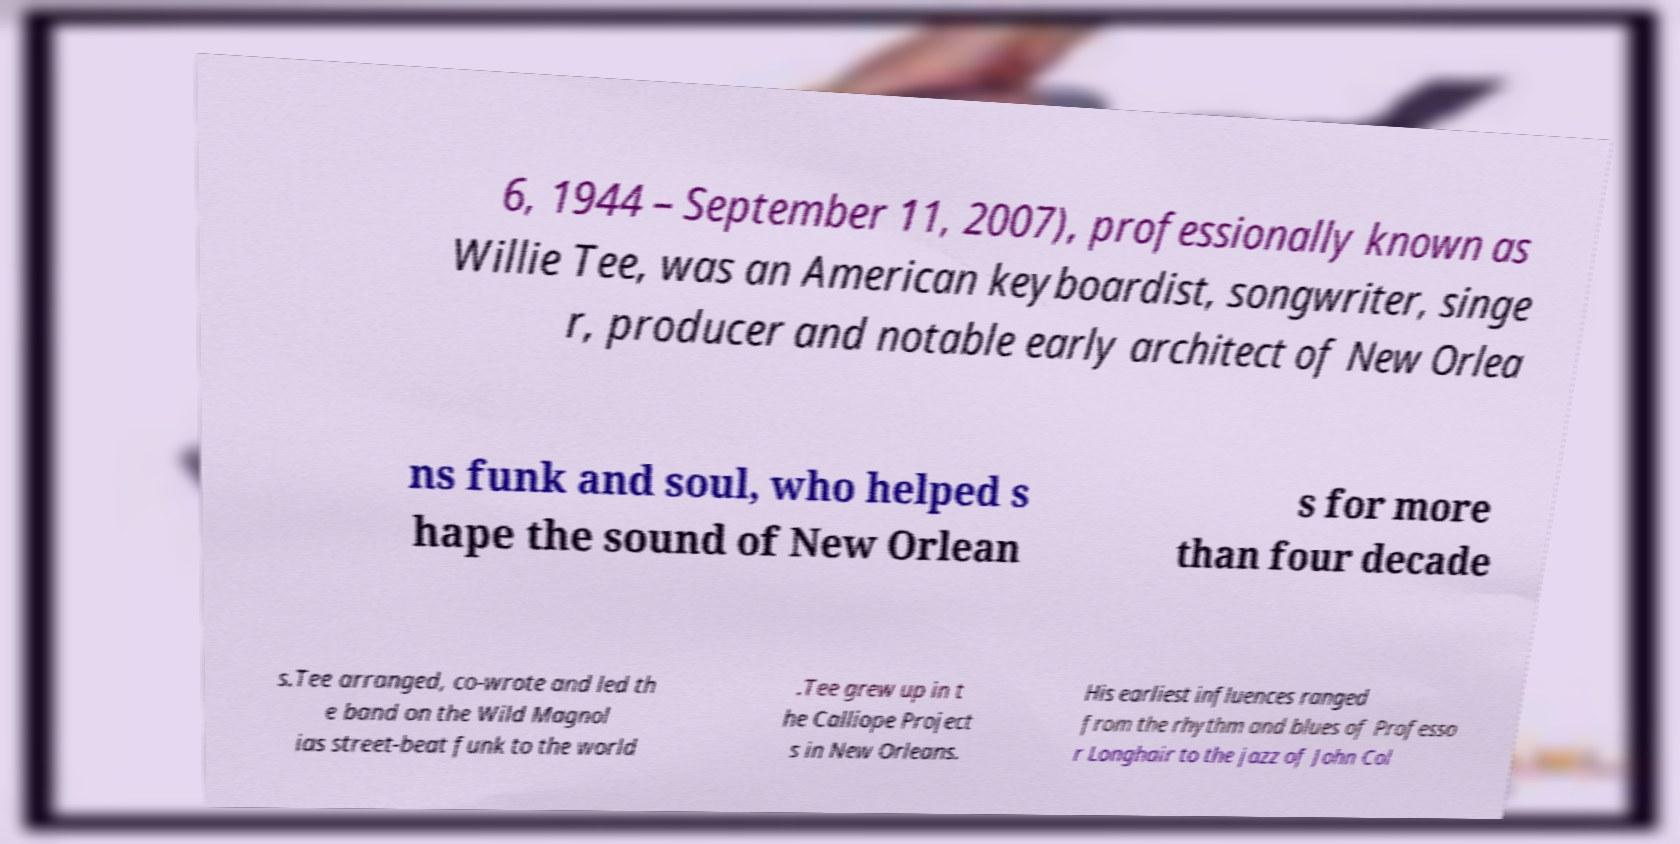Could you assist in decoding the text presented in this image and type it out clearly? 6, 1944 – September 11, 2007), professionally known as Willie Tee, was an American keyboardist, songwriter, singe r, producer and notable early architect of New Orlea ns funk and soul, who helped s hape the sound of New Orlean s for more than four decade s.Tee arranged, co-wrote and led th e band on the Wild Magnol ias street-beat funk to the world .Tee grew up in t he Calliope Project s in New Orleans. His earliest influences ranged from the rhythm and blues of Professo r Longhair to the jazz of John Col 